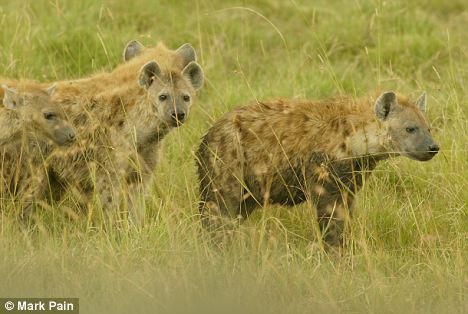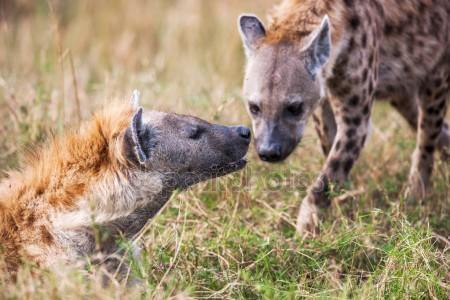The first image is the image on the left, the second image is the image on the right. For the images shown, is this caption "The hyena in the image on the left is carrying a small animal in its mouth." true? Answer yes or no. No. The first image is the image on the left, the second image is the image on the right. Examine the images to the left and right. Is the description "An image shows one hyena, which is walking with at least part of an animal in its mouth." accurate? Answer yes or no. No. 